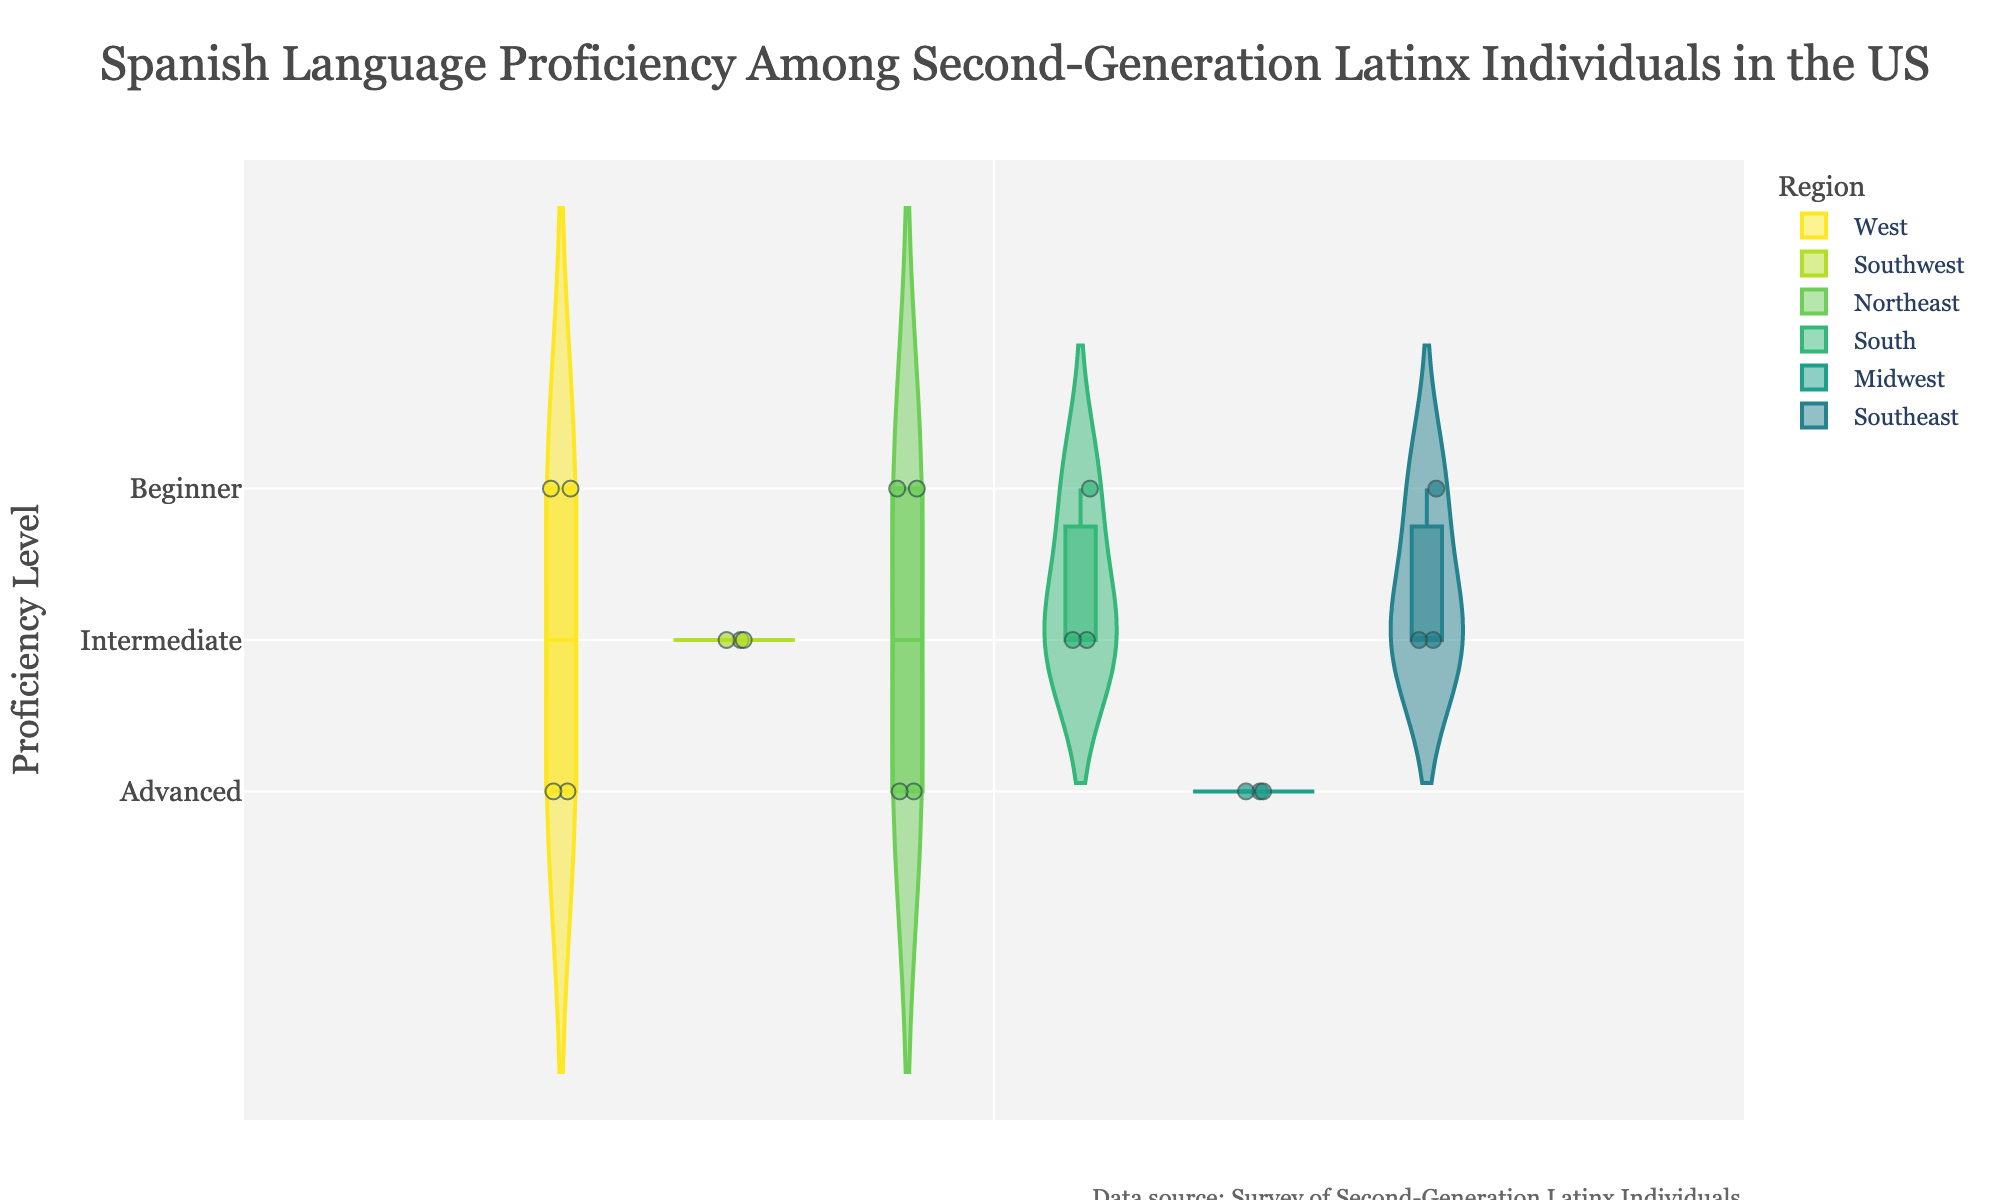What is the title of the figure? The title of the figure is prominently displayed at the top and reads "Spanish Language Proficiency Among Second-Generation Latinx Individuals in the US".
Answer: Spanish Language Proficiency Among Second-Generation Latinx Individuals in the US Which proficiency level has the highest number of data points in the West region? By observing the jittered points in the region colored for the West, it is evident that the "Advanced" proficiency level has the most data points.
Answer: Advanced How many regions are represented in the figure? The plot's legend displays the different regions, each identified with unique colors. There are six regions listed: West, Southwest, Northeast, South, Midwest, and Southeast.
Answer: Six Which proficiency levels are represented in the Northeast region? By looking at the colors corresponding to the Northeast region, you can observe that data points are present in the Beginner, Intermediate, and Advanced proficiency levels.
Answer: Beginner, Intermediate, Advanced What is the total number of data points for individuals with intermediate proficiency? Count the individual jittered points on the violin plots for the "Intermediate" proficiency across all regions. There are two points in the Northeast, four points in the Southwest, one in the South, one in the Midwest, and one in the Southeast, totaling nine.
Answer: Nine Which region has the most advanced Spanish language proficiency points compared to other regions? By counting the jittered points within the "Advanced" proficiency section of each region and comparing them, it is clear that the West region has the most points.
Answer: West Are there more males or females in the Advanced proficiency level? By analyzing the gender of the individuals plotted in the Advanced proficiency level, you note that there are more males represented.
Answer: Males Which region has the least number of individuals in the Beginner proficiency level? Observing the jittered points for the Beginner proficiency level across each region, the Southwest region has the least (none) followed by the Southeast and the Midwest.
Answer: Southwest What is the distribution shape of the Intermediate proficiency level in the Midwest region? The distribution of the Intermediate proficiency level in the Midwest region is narrow with only one data point, indicating low variation.
Answer: Narrow, low variation What does the annotation at the bottom of the plot signify? The annotation at the bottom of the plot indicates the data source, which is the "Survey of Second-Generation Latinx Individuals".
Answer: Survey of Second-Generation Latinx Individuals 